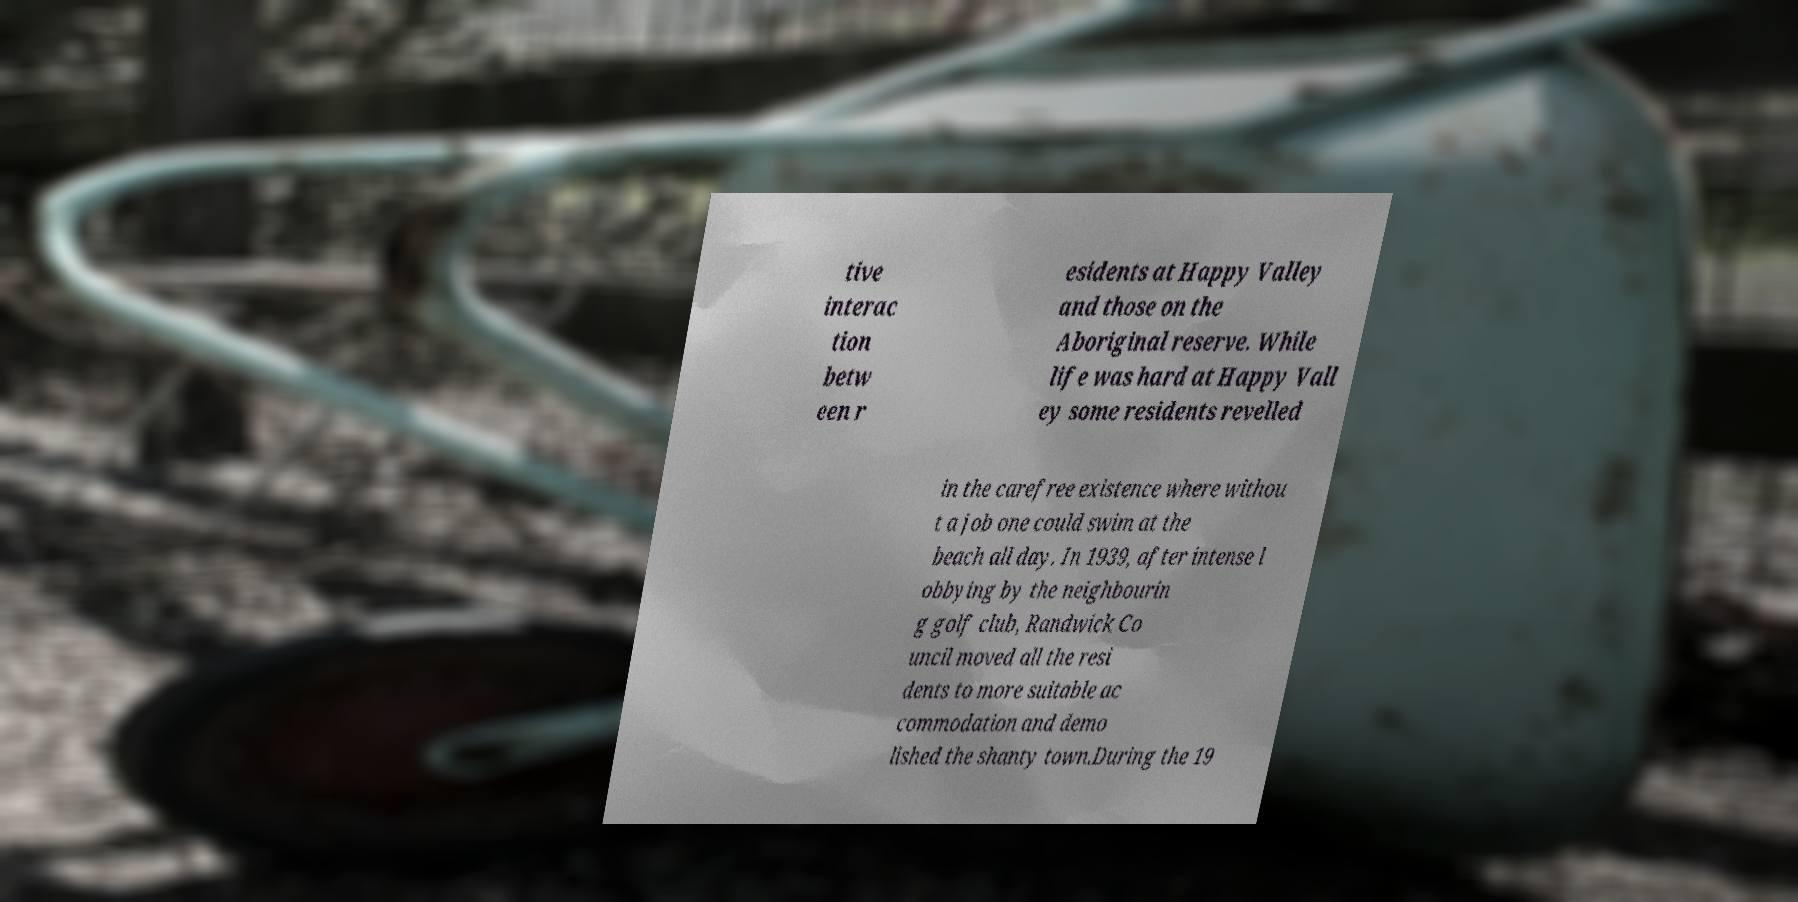Could you assist in decoding the text presented in this image and type it out clearly? tive interac tion betw een r esidents at Happy Valley and those on the Aboriginal reserve. While life was hard at Happy Vall ey some residents revelled in the carefree existence where withou t a job one could swim at the beach all day. In 1939, after intense l obbying by the neighbourin g golf club, Randwick Co uncil moved all the resi dents to more suitable ac commodation and demo lished the shanty town.During the 19 